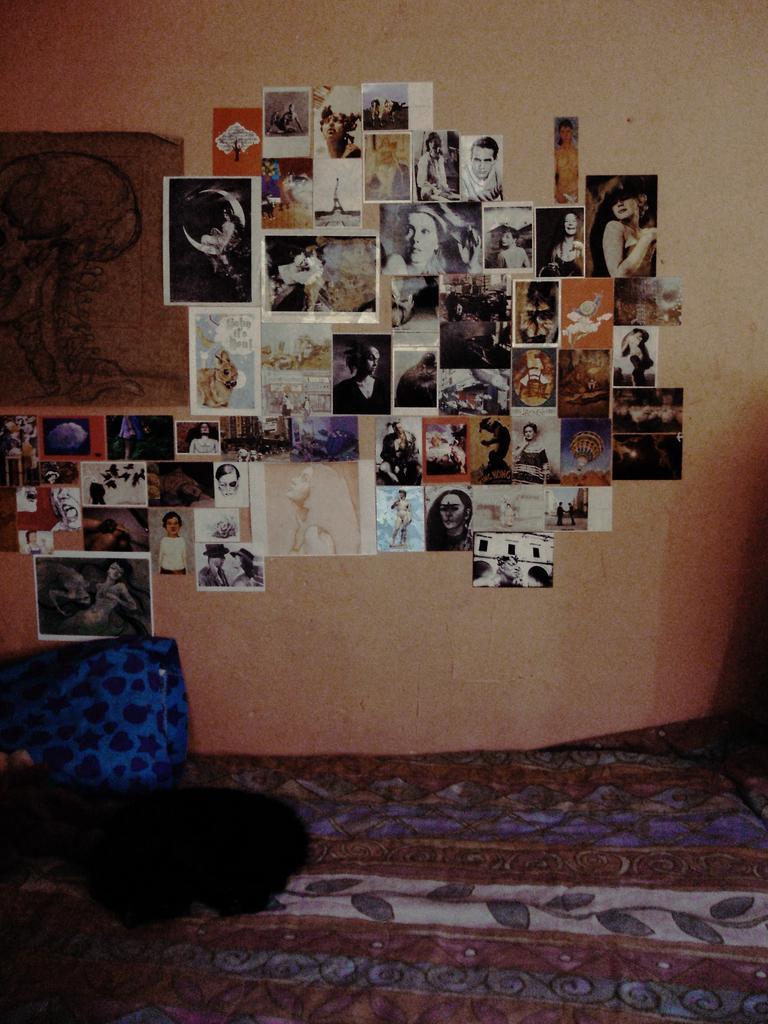Describe this image in one or two sentences. In this image, we can see a wall with so many photographs and poster. At the bottom, there is a cloth. Here we can see a pillow on the cloth. 